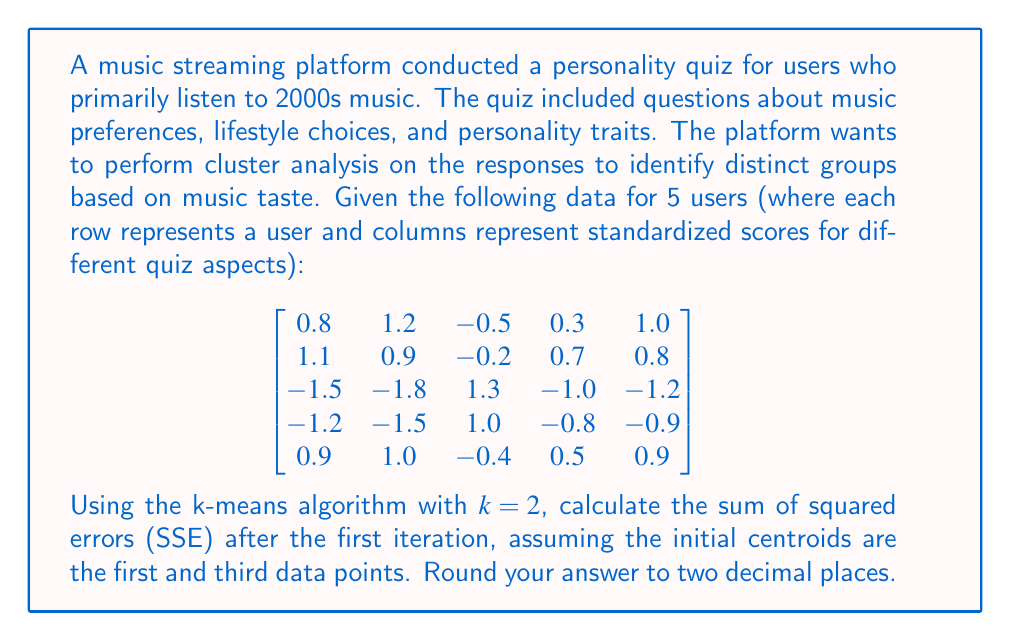Help me with this question. Let's approach this step-by-step:

1) First, we identify the initial centroids:
   Centroid 1: $[0.8, 1.2, -0.5, 0.3, 1.0]$
   Centroid 2: $[-1.5, -1.8, 1.3, -1.0, -1.2]$

2) We need to assign each data point to the nearest centroid. To do this, we'll calculate the Euclidean distance between each point and both centroids.

3) For a point $x = [x_1, x_2, x_3, x_4, x_5]$ and a centroid $c = [c_1, c_2, c_3, c_4, c_5]$, the Euclidean distance is:

   $$d = \sqrt{(x_1-c_1)^2 + (x_2-c_2)^2 + (x_3-c_3)^2 + (x_4-c_4)^2 + (x_5-c_5)^2}$$

4) Let's calculate these distances:

   For point 1: 
   To Centroid 1: $d = 0$ (it is Centroid 1)
   To Centroid 2: $d = 5.39$

   For point 2:
   To Centroid 1: $d = 0.58$
   To Centroid 2: $d = 5.63$

   For point 3:
   To Centroid 1: $d = 5.39$
   To Centroid 2: $d = 0$ (it is Centroid 2)

   For point 4:
   To Centroid 1: $d = 4.62$
   To Centroid 2: $d = 0.77$

   For point 5:
   To Centroid 1: $d = 0.26$
   To Centroid 2: $d = 5.52$

5) Assign each point to the nearest centroid:
   Points 1, 2, and 5 are assigned to Centroid 1
   Points 3 and 4 are assigned to Centroid 2

6) The SSE is the sum of the squared distances between each point and its assigned centroid:

   SSE = $0^2 + 0.58^2 + 0^2 + 0.77^2 + 0.26^2$

7) Calculate:
   SSE = $0 + 0.3364 + 0 + 0.5929 + 0.0676 = 0.9969$

8) Rounding to two decimal places: 1.00
Answer: 1.00 